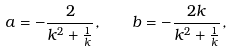Convert formula to latex. <formula><loc_0><loc_0><loc_500><loc_500>a = - \frac { 2 } { k ^ { 2 } + \frac { 1 } { k } } , \quad b = - \frac { 2 k } { k ^ { 2 } + \frac { 1 } { k } } ,</formula> 